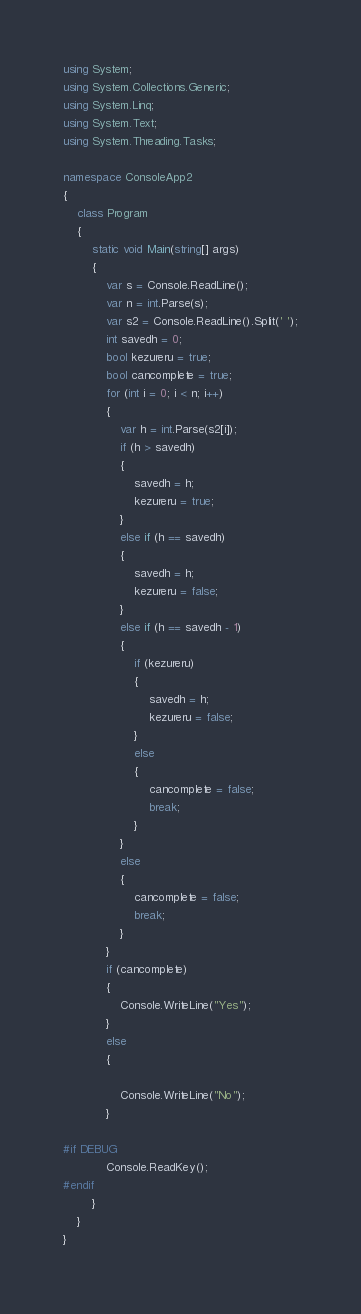<code> <loc_0><loc_0><loc_500><loc_500><_C#_>using System;
using System.Collections.Generic;
using System.Linq;
using System.Text;
using System.Threading.Tasks;

namespace ConsoleApp2
{
    class Program
    {
        static void Main(string[] args)
        {
            var s = Console.ReadLine();
            var n = int.Parse(s);
            var s2 = Console.ReadLine().Split(' ');
            int savedh = 0;
            bool kezureru = true;
            bool cancomplete = true;
            for (int i = 0; i < n; i++)
            {
                var h = int.Parse(s2[i]);
                if (h > savedh)
                {
                    savedh = h;
                    kezureru = true;
                }
                else if (h == savedh)
                {
                    savedh = h;
                    kezureru = false;
                }
                else if (h == savedh - 1)
                {
                    if (kezureru)
                    {
                        savedh = h;
                        kezureru = false;
                    }
                    else
                    {
                        cancomplete = false;
                        break;
                    }
                }
                else
                {
                    cancomplete = false;
                    break;
                }
            }
            if (cancomplete)
            {
                Console.WriteLine("Yes");
            }
            else
            {

                Console.WriteLine("No");
            }

#if DEBUG
            Console.ReadKey();
#endif
        }
    }
}
</code> 